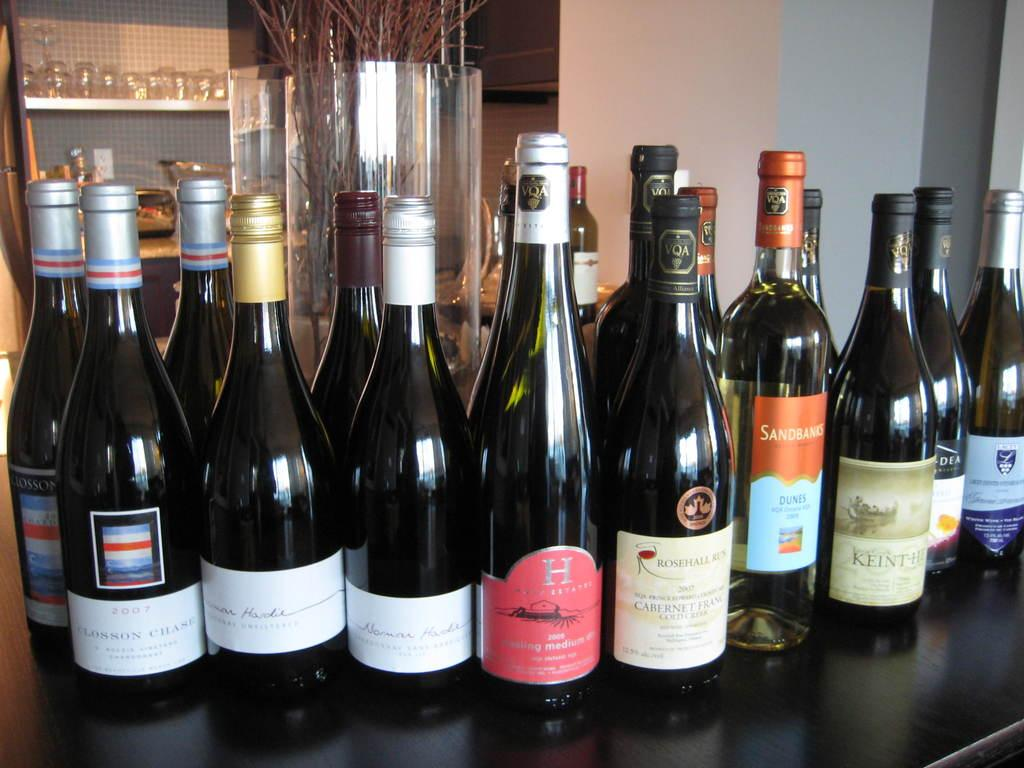<image>
Write a terse but informative summary of the picture. Bottles of wine with one that has a giant letter H on it. 